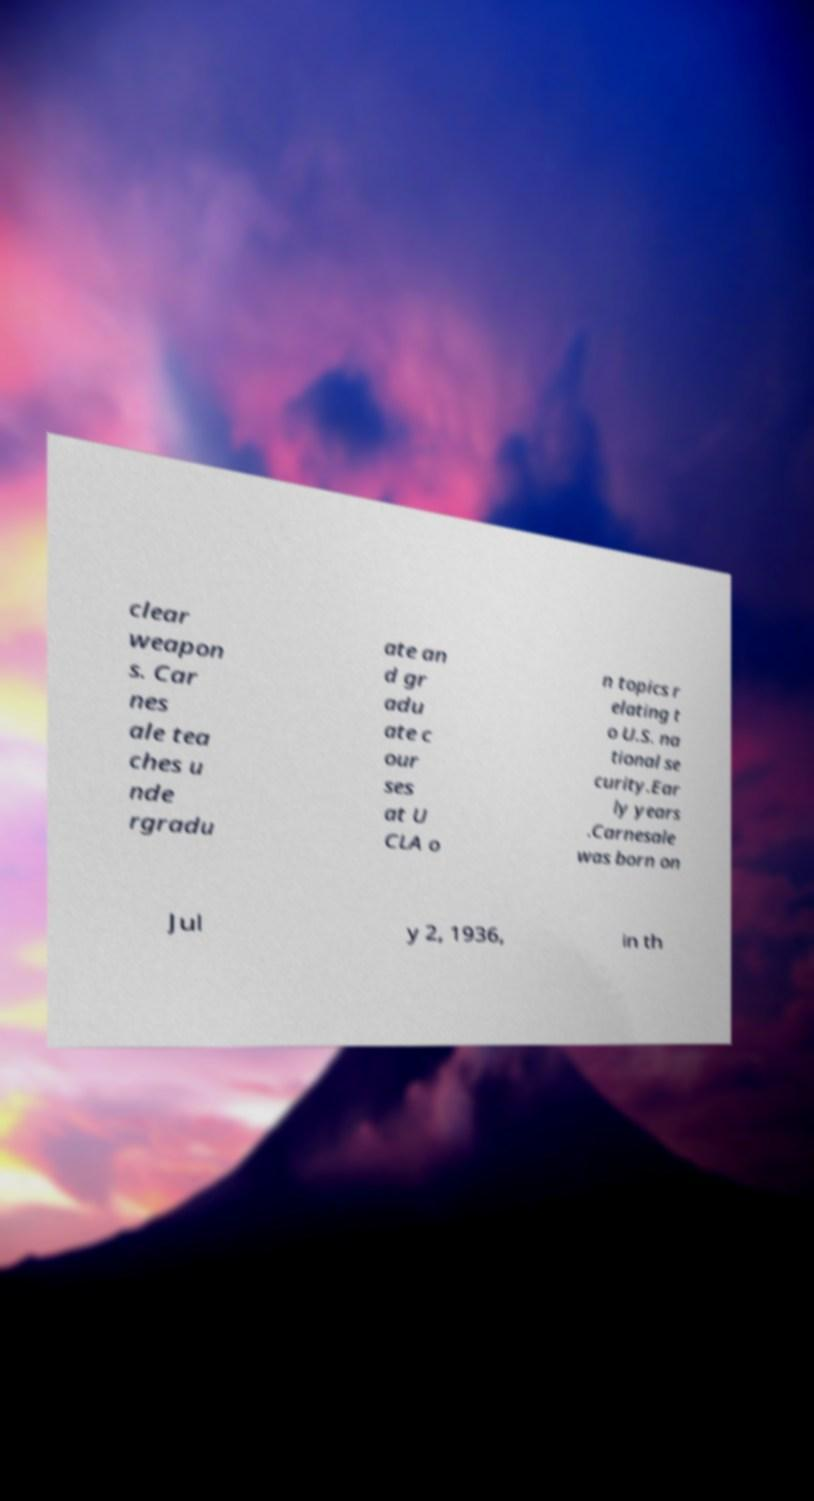Please read and relay the text visible in this image. What does it say? clear weapon s. Car nes ale tea ches u nde rgradu ate an d gr adu ate c our ses at U CLA o n topics r elating t o U.S. na tional se curity.Ear ly years .Carnesale was born on Jul y 2, 1936, in th 